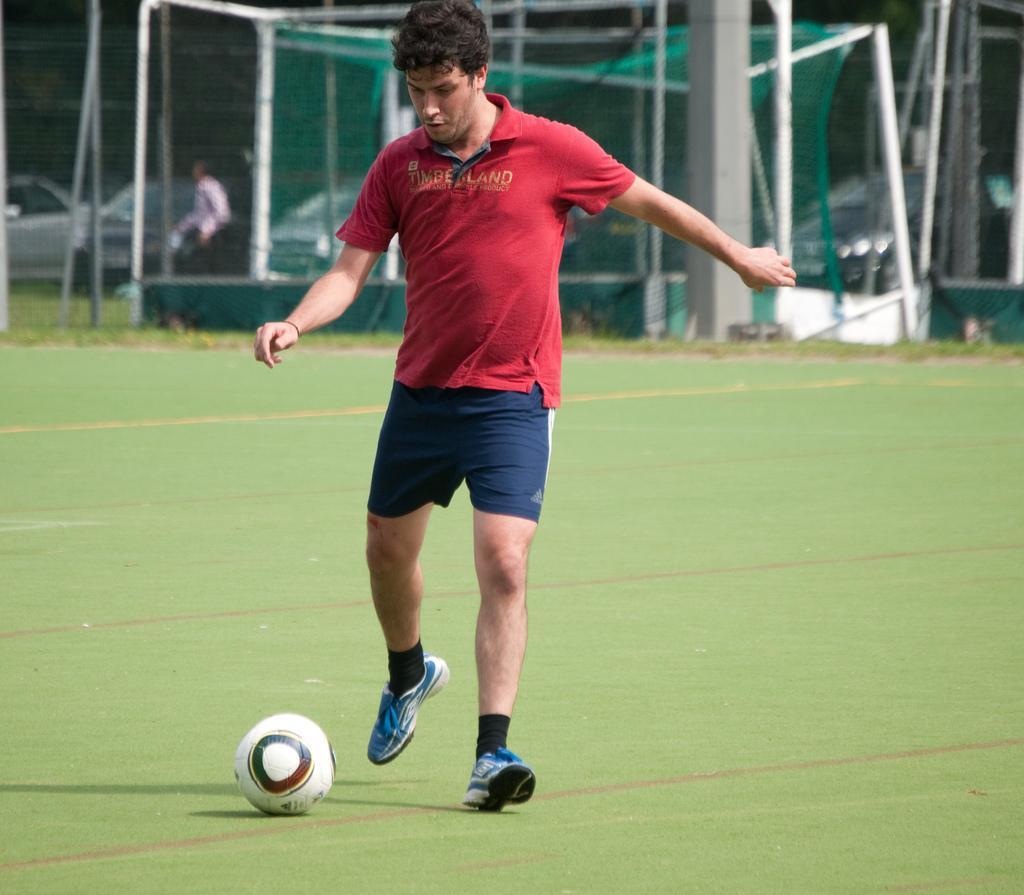In one or two sentences, can you explain what this image depicts? In this picture there is a person walking. At the back there is a person and there are cars and there is a fence. At the bottom there is grass and there is a ball. 